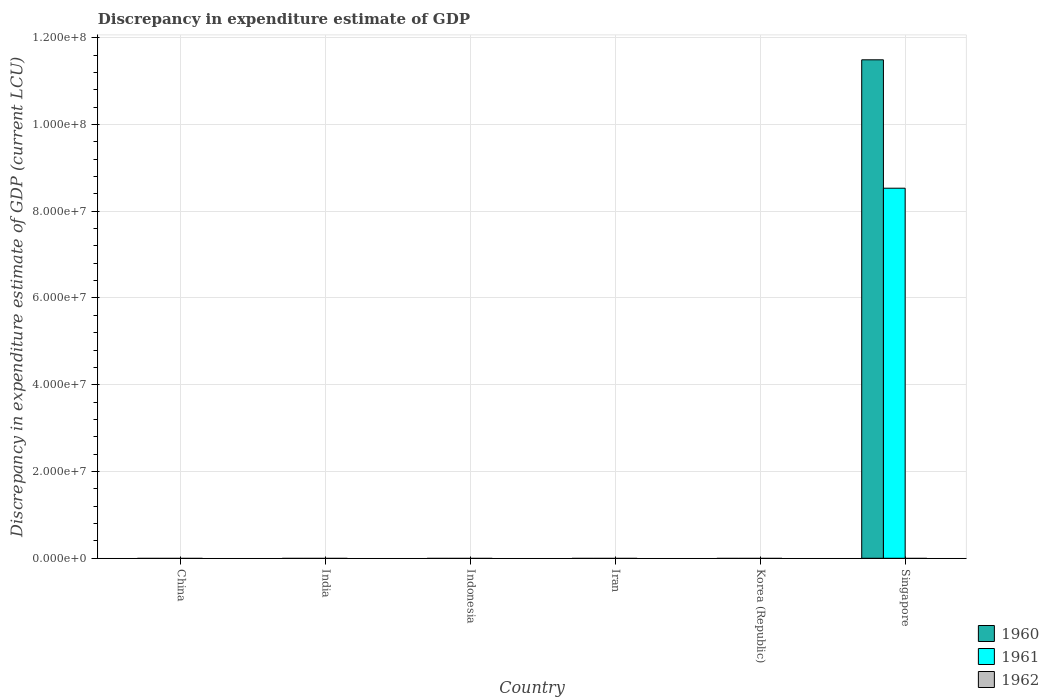How many different coloured bars are there?
Your response must be concise. 2. How many bars are there on the 5th tick from the left?
Your answer should be compact. 0. What is the label of the 4th group of bars from the left?
Ensure brevity in your answer.  Iran. What is the discrepancy in expenditure estimate of GDP in 1961 in India?
Offer a terse response. 0. Across all countries, what is the maximum discrepancy in expenditure estimate of GDP in 1960?
Keep it short and to the point. 1.15e+08. Across all countries, what is the minimum discrepancy in expenditure estimate of GDP in 1962?
Ensure brevity in your answer.  0. In which country was the discrepancy in expenditure estimate of GDP in 1960 maximum?
Provide a short and direct response. Singapore. What is the total discrepancy in expenditure estimate of GDP in 1961 in the graph?
Offer a very short reply. 8.53e+07. What is the difference between the discrepancy in expenditure estimate of GDP in 1962 in China and the discrepancy in expenditure estimate of GDP in 1961 in Korea (Republic)?
Your response must be concise. 0. What is the average discrepancy in expenditure estimate of GDP in 1961 per country?
Make the answer very short. 1.42e+07. In how many countries, is the discrepancy in expenditure estimate of GDP in 1962 greater than 56000000 LCU?
Offer a very short reply. 0. What is the difference between the highest and the lowest discrepancy in expenditure estimate of GDP in 1961?
Your answer should be compact. 8.53e+07. In how many countries, is the discrepancy in expenditure estimate of GDP in 1960 greater than the average discrepancy in expenditure estimate of GDP in 1960 taken over all countries?
Keep it short and to the point. 1. How many countries are there in the graph?
Give a very brief answer. 6. Are the values on the major ticks of Y-axis written in scientific E-notation?
Your answer should be compact. Yes. How many legend labels are there?
Ensure brevity in your answer.  3. What is the title of the graph?
Provide a succinct answer. Discrepancy in expenditure estimate of GDP. Does "1972" appear as one of the legend labels in the graph?
Provide a short and direct response. No. What is the label or title of the Y-axis?
Make the answer very short. Discrepancy in expenditure estimate of GDP (current LCU). What is the Discrepancy in expenditure estimate of GDP (current LCU) in 1960 in China?
Make the answer very short. 0. What is the Discrepancy in expenditure estimate of GDP (current LCU) in 1961 in China?
Provide a succinct answer. 0. What is the Discrepancy in expenditure estimate of GDP (current LCU) of 1960 in Indonesia?
Your answer should be compact. 0. What is the Discrepancy in expenditure estimate of GDP (current LCU) of 1960 in Iran?
Keep it short and to the point. 0. What is the Discrepancy in expenditure estimate of GDP (current LCU) in 1960 in Korea (Republic)?
Provide a short and direct response. 0. What is the Discrepancy in expenditure estimate of GDP (current LCU) of 1961 in Korea (Republic)?
Provide a succinct answer. 0. What is the Discrepancy in expenditure estimate of GDP (current LCU) of 1960 in Singapore?
Make the answer very short. 1.15e+08. What is the Discrepancy in expenditure estimate of GDP (current LCU) of 1961 in Singapore?
Your answer should be very brief. 8.53e+07. What is the Discrepancy in expenditure estimate of GDP (current LCU) of 1962 in Singapore?
Keep it short and to the point. 0. Across all countries, what is the maximum Discrepancy in expenditure estimate of GDP (current LCU) of 1960?
Your response must be concise. 1.15e+08. Across all countries, what is the maximum Discrepancy in expenditure estimate of GDP (current LCU) in 1961?
Provide a succinct answer. 8.53e+07. What is the total Discrepancy in expenditure estimate of GDP (current LCU) in 1960 in the graph?
Offer a terse response. 1.15e+08. What is the total Discrepancy in expenditure estimate of GDP (current LCU) in 1961 in the graph?
Give a very brief answer. 8.53e+07. What is the average Discrepancy in expenditure estimate of GDP (current LCU) in 1960 per country?
Provide a succinct answer. 1.92e+07. What is the average Discrepancy in expenditure estimate of GDP (current LCU) of 1961 per country?
Provide a short and direct response. 1.42e+07. What is the difference between the Discrepancy in expenditure estimate of GDP (current LCU) in 1960 and Discrepancy in expenditure estimate of GDP (current LCU) in 1961 in Singapore?
Your response must be concise. 2.96e+07. What is the difference between the highest and the lowest Discrepancy in expenditure estimate of GDP (current LCU) of 1960?
Offer a very short reply. 1.15e+08. What is the difference between the highest and the lowest Discrepancy in expenditure estimate of GDP (current LCU) in 1961?
Your answer should be very brief. 8.53e+07. 